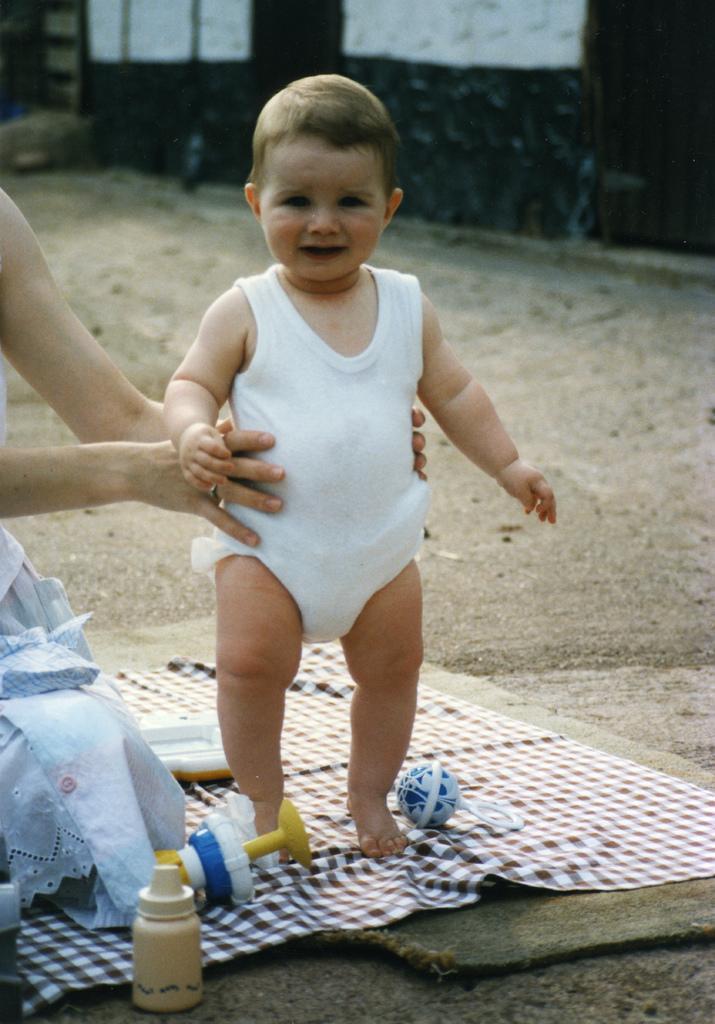Please provide a concise description of this image. In this image we can see a woman holding a baby with her hands. In the foreground we can see a bottle, toys placed on the surface. In the background, we can see a building. 